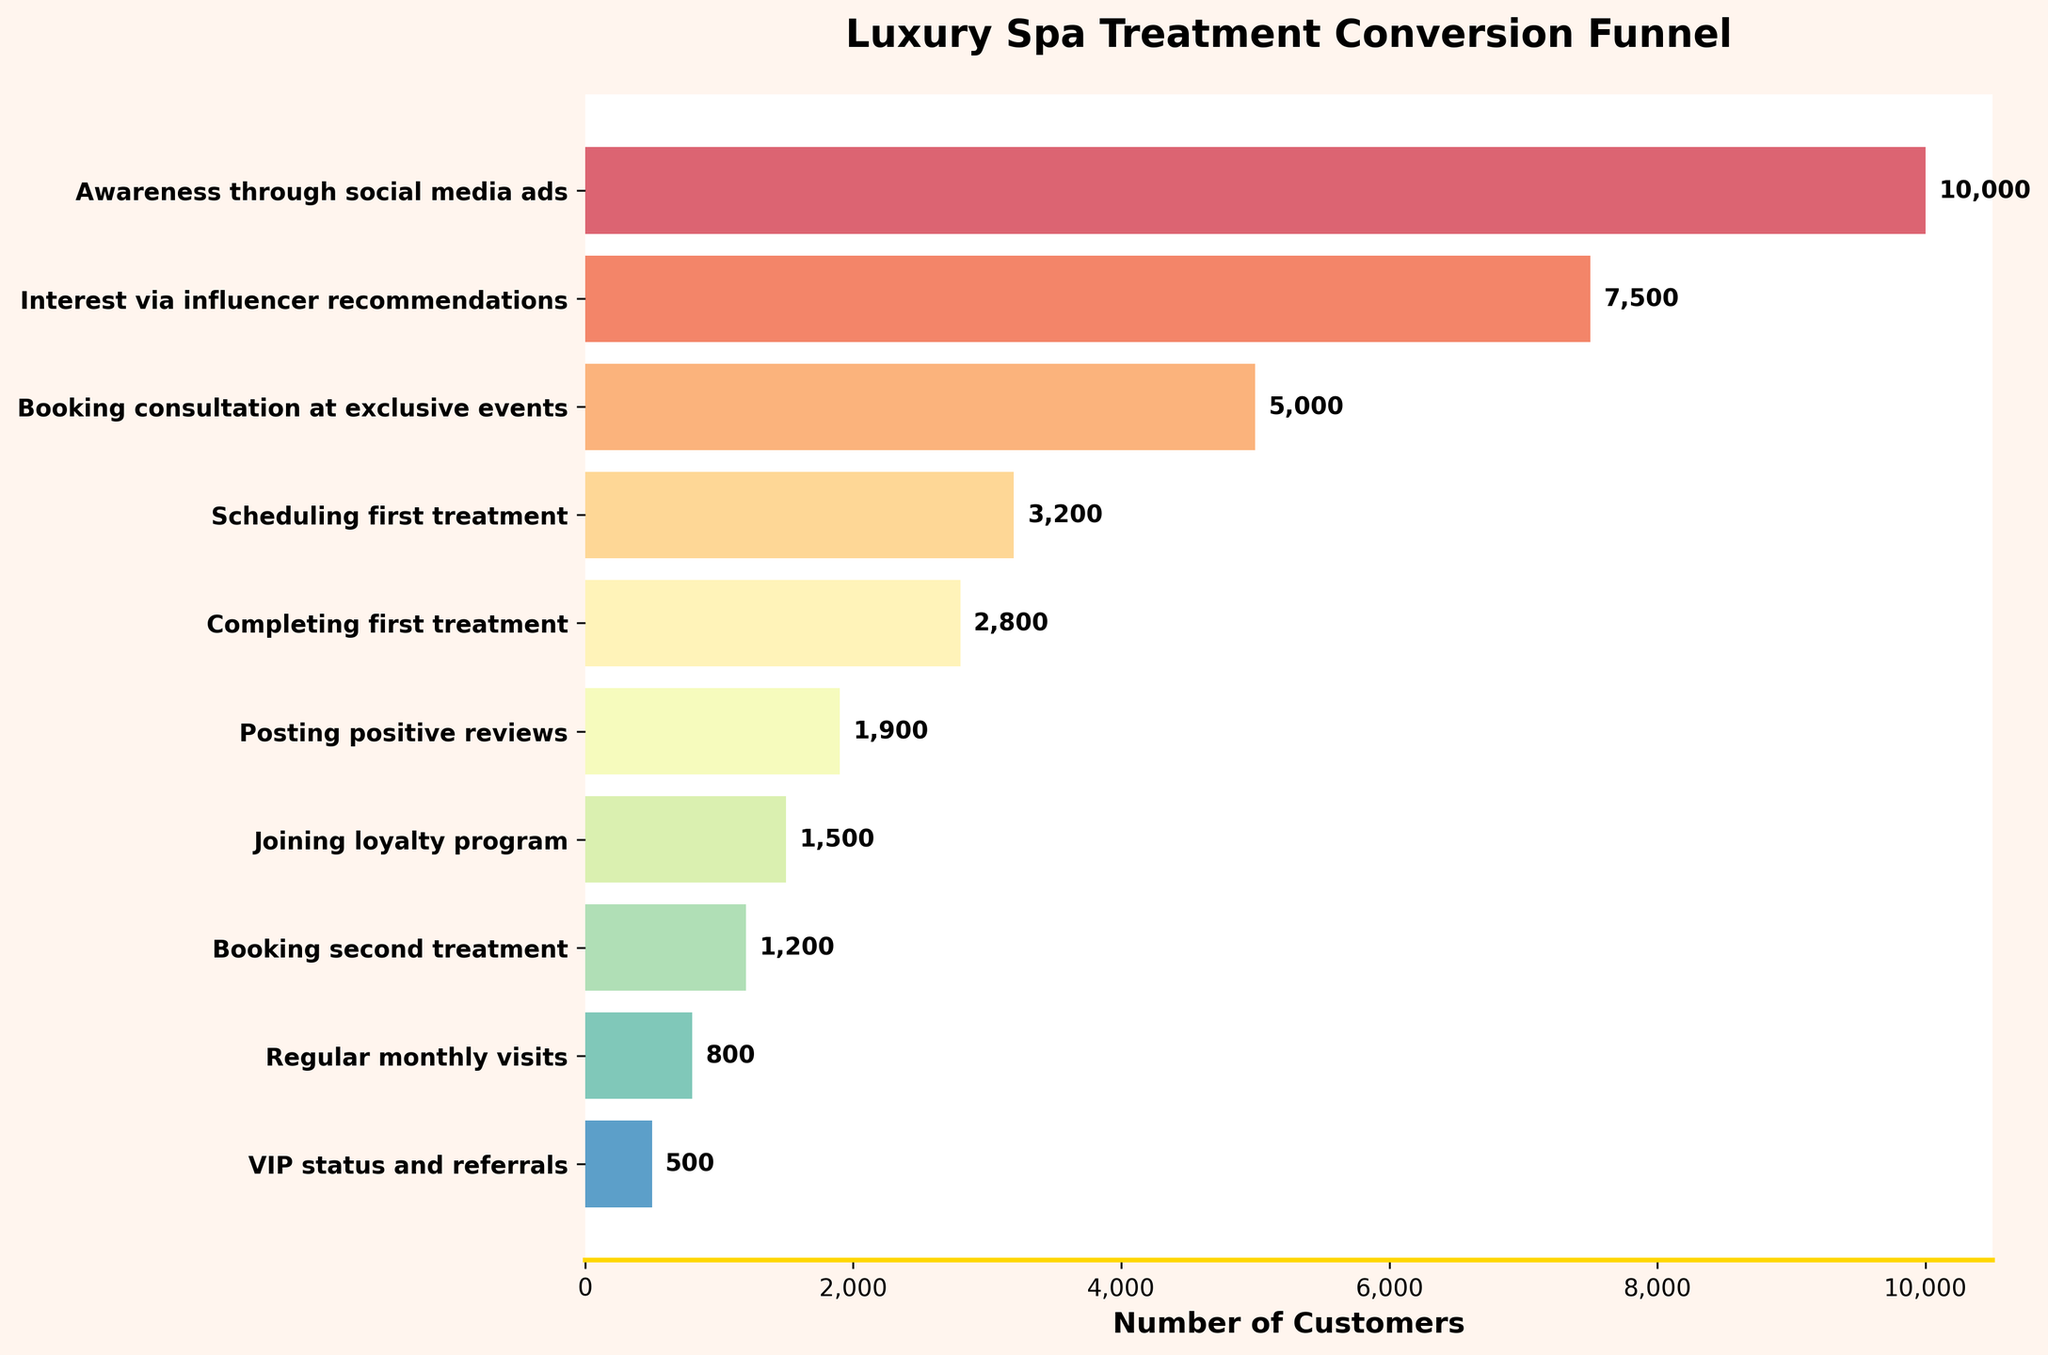Which stage has the highest number of customers? The stage with the highest number of customers is the first one listed at the top of the funnel. This top stage shows "Awareness through social media ads" with 10,000 customers.
Answer: Awareness through social media ads How many customers move from "Scheduling first treatment" to "Completing first treatment"? To find the number of customers moving from "Scheduling first treatment" to "Completing first treatment," subtract the number at the second stage from the number at the first stage: 3,200 - 2,800 = 400.
Answer: 400 By how much does the number of customers decrease from "Interest via influencer recommendations" to "Booking consultation at exclusive events"? The number of customers decreases from 7,500 to 5,000 between these stages. Therefore, the decrease is calculated as 7,500 - 5,000 = 2,500.
Answer: 2,500 What percentage of customers from "Completing first treatment" post positive reviews? Divide the number of customers posting positive reviews by the number completing the first treatment and multiply by 100: (1,900 / 2,800) * 100 ≈ 67.86%.
Answer: 67.86% Which stage represents the transition with the smallest number of customers? The final stage "VIP status and referrals," which has 500 customers, represents the smallest number of customers in this funnel.
Answer: VIP status and referrals How many customers are lost between "Joining loyalty program" and "Booking second treatment"? Subtract the number of customers booking the second treatment from those joining the loyalty program: 1,500 - 1,200 = 300.
Answer: 300 By what factor does the number of customers decrease from "Regular monthly visits" to "VIP status and referrals"? To find the factor of decrease, divide the number of customers at "Regular monthly visits" by the number at "VIP status and referrals": 800 / 500 = 1.6.
Answer: 1.6 Which stages have fewer than 2,000 customers? The stages with fewer than 2,000 customers are "Posting positive reviews" (1,900), "Joining loyalty program" (1,500), "Booking second treatment" (1,200), "Regular monthly visits" (800), and "VIP status and referrals" (500).
Answer: Posting positive reviews, Joining loyalty program, Booking second treatment, Regular monthly visits, VIP status and referrals What is the sum of customers across all stages? Add the number of customers at each stage: 10,000 + 7,500 + 5,000 + 3,200 + 2,800 + 1,900 + 1,500 + 1,200 + 800 + 500 = 34,400.
Answer: 34,400 